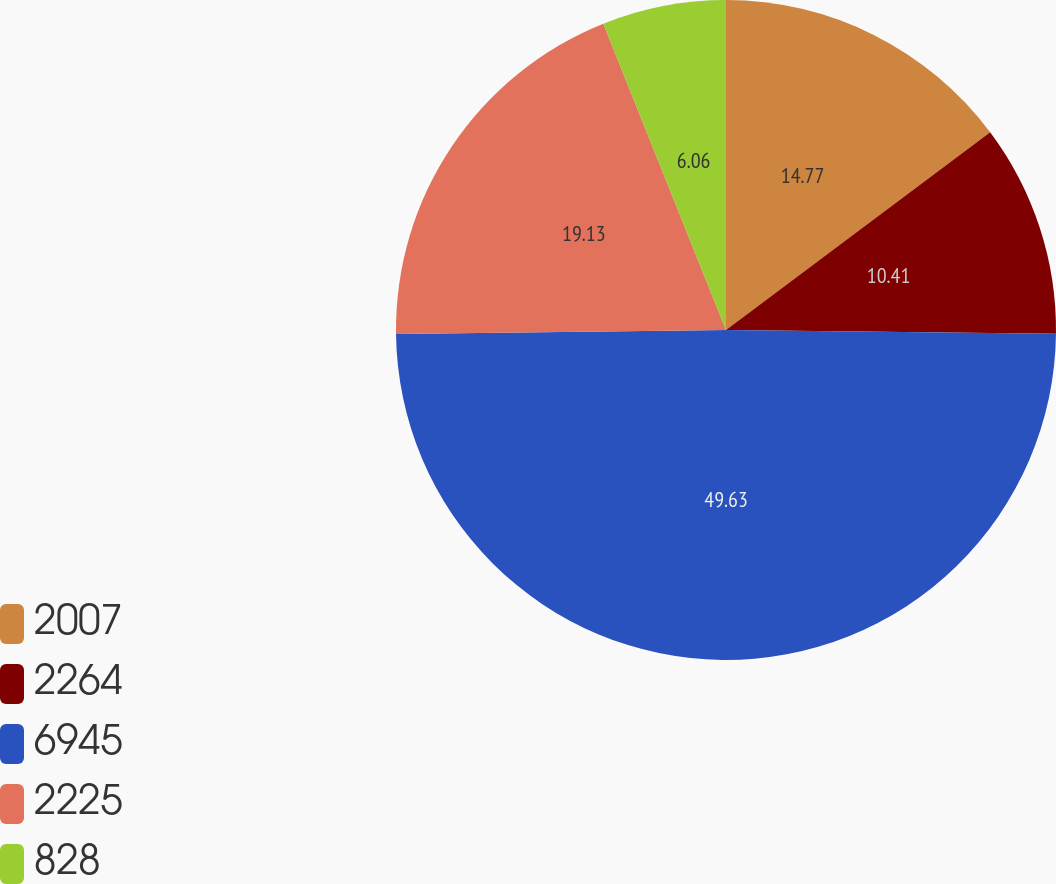<chart> <loc_0><loc_0><loc_500><loc_500><pie_chart><fcel>2007<fcel>2264<fcel>6945<fcel>2225<fcel>828<nl><fcel>14.77%<fcel>10.41%<fcel>49.63%<fcel>19.13%<fcel>6.06%<nl></chart> 